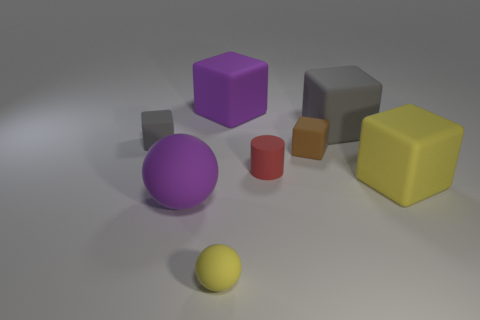Subtract all gray blocks. How many blocks are left? 3 Add 1 yellow matte objects. How many objects exist? 9 Subtract 2 blocks. How many blocks are left? 3 Subtract all small matte cylinders. Subtract all tiny spheres. How many objects are left? 6 Add 6 big purple rubber spheres. How many big purple rubber spheres are left? 7 Add 4 purple blocks. How many purple blocks exist? 5 Subtract all brown blocks. How many blocks are left? 4 Subtract 0 blue blocks. How many objects are left? 8 Subtract all balls. How many objects are left? 6 Subtract all yellow spheres. Subtract all green cylinders. How many spheres are left? 1 